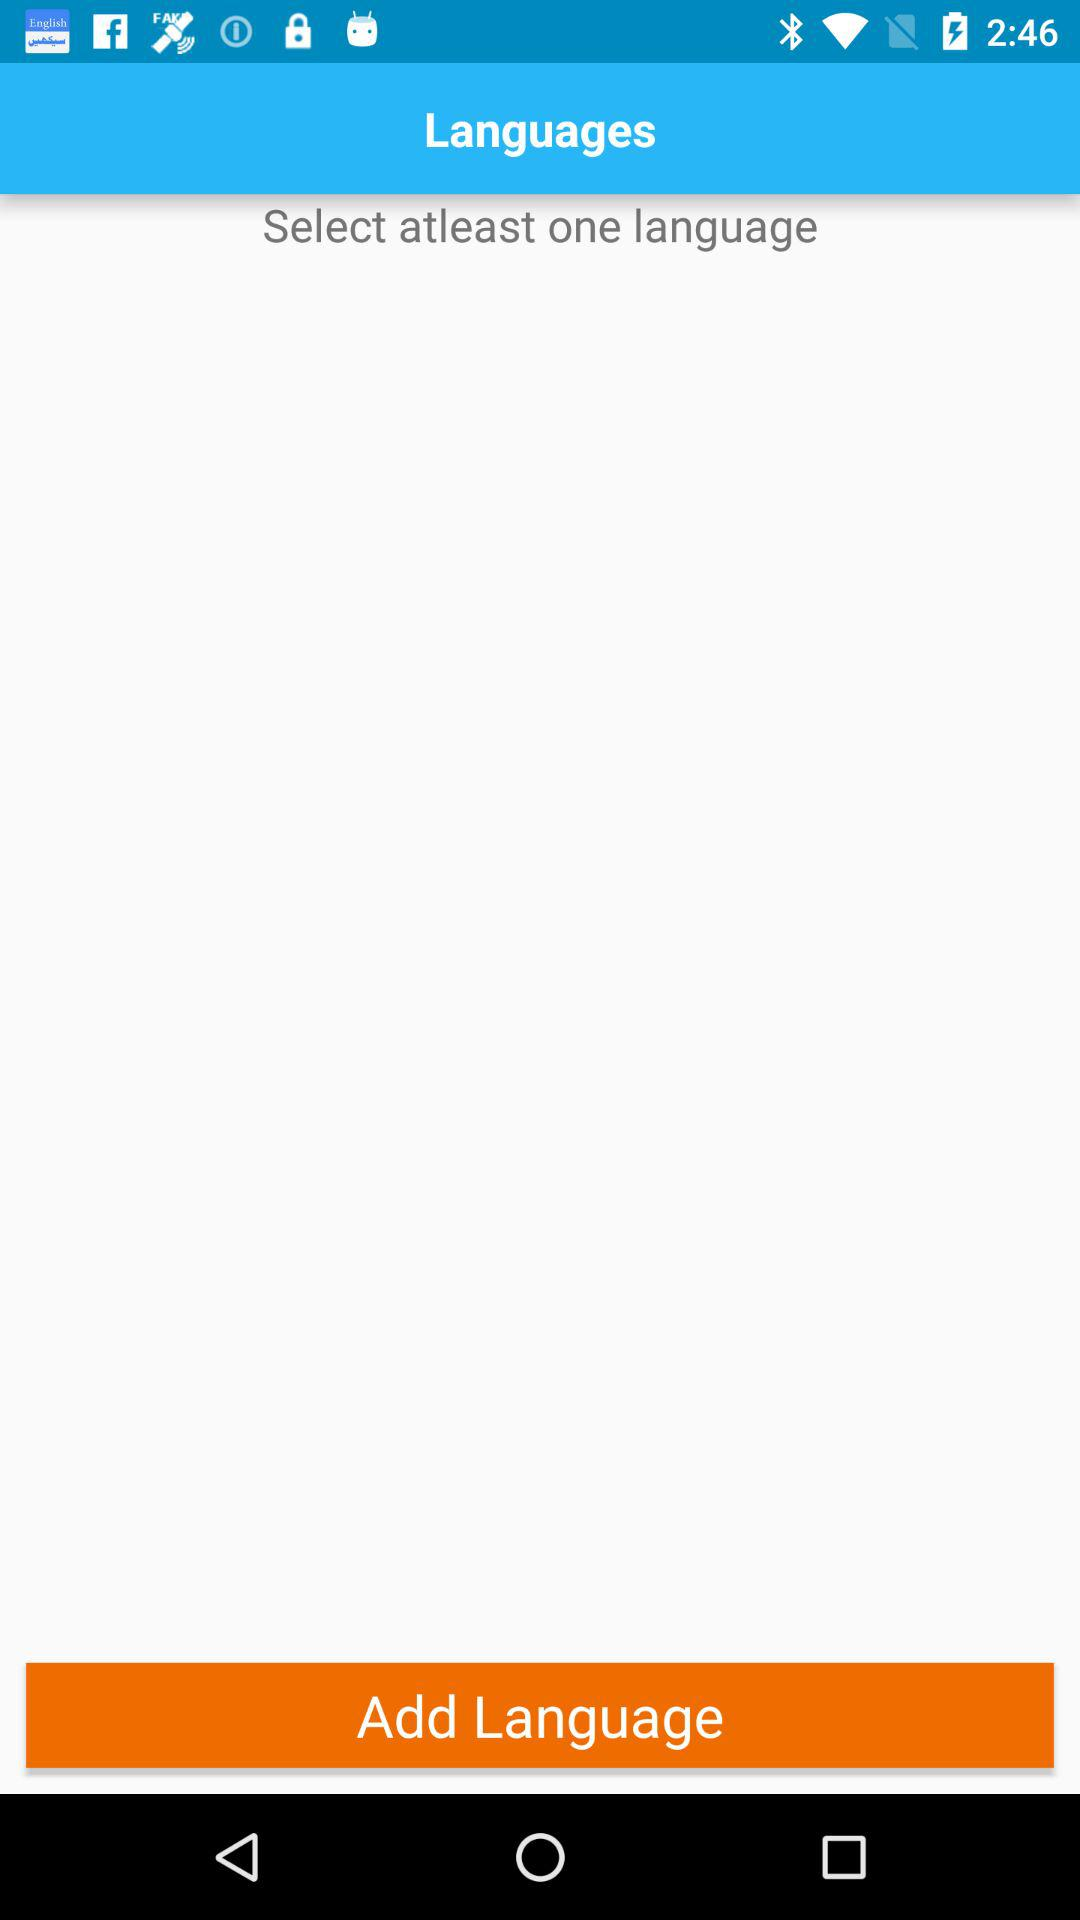What is the minimum number of languages that can be selected? The minimum number of languages that can be selected is one. 